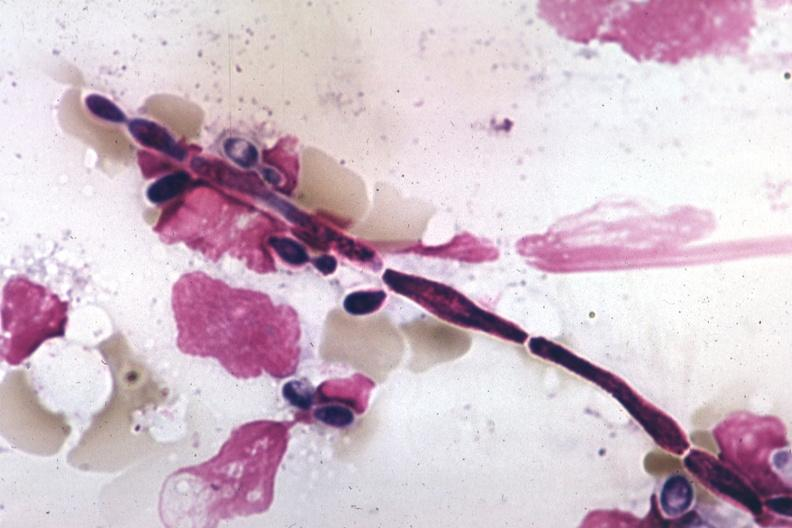s hand present?
Answer the question using a single word or phrase. No 